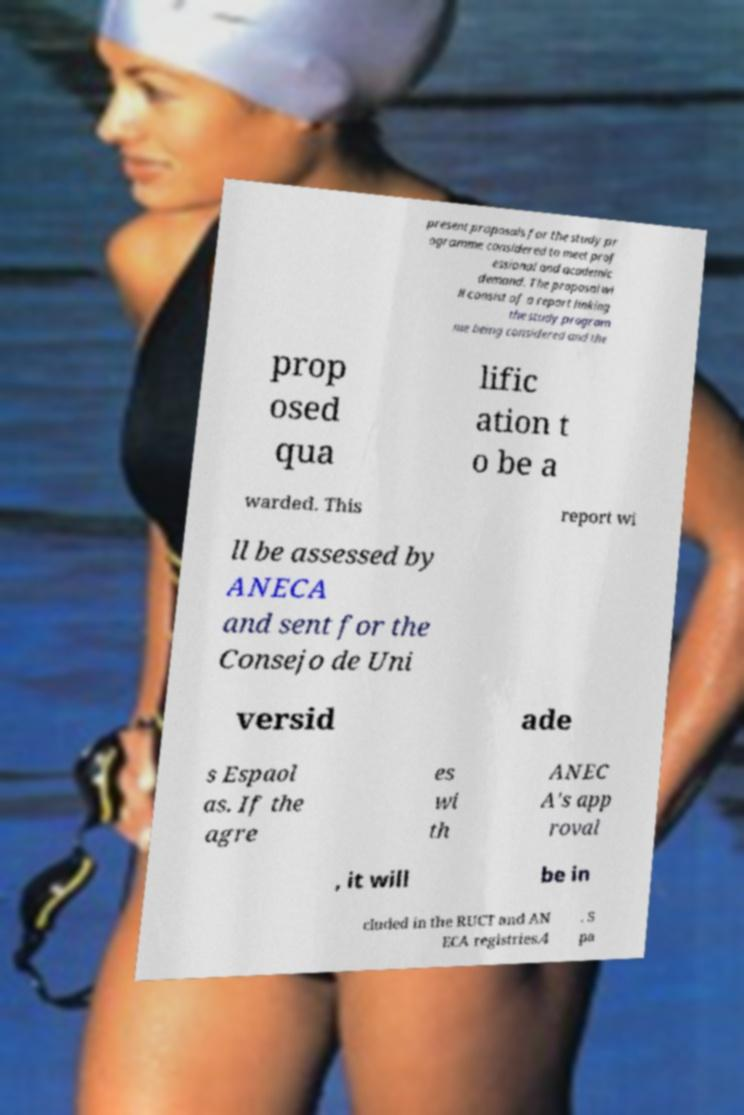Can you accurately transcribe the text from the provided image for me? present proposals for the study pr ogramme considered to meet prof essional and academic demand. The proposal wi ll consist of a report linking the study program me being considered and the prop osed qua lific ation t o be a warded. This report wi ll be assessed by ANECA and sent for the Consejo de Uni versid ade s Espaol as. If the agre es wi th ANEC A's app roval , it will be in cluded in the RUCT and AN ECA registries.4 . S pa 